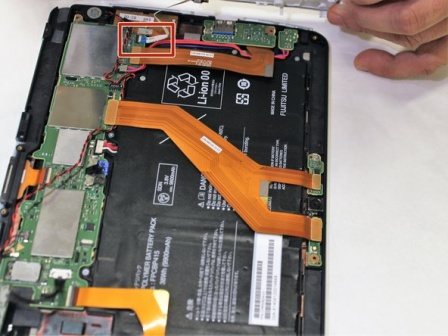What could be the reason for someone to open up their tablet like this? Opening up a tablet like this is typically done for repair or maintenance purposes. It might be to replace a faulty component such as a battery, fix a loose connection, or upgrade parts of the hardware to improve performance. It’s a delicate process that requires careful handling to avoid damaging sensitive electronics. What precautions should be taken when doing this? When opening a device like this, it's important to use the correct tools, such as non-magnetic screwdrivers and ESD-safe tweezers, to prevent static electricity damage. The workspace should be clean and organized to avoid losing small parts. Additionally, one should be familiar with the device layout and sensitive areas to avoid accidental damage during disassembly or reassembly. 